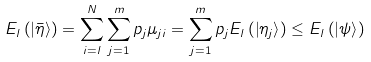Convert formula to latex. <formula><loc_0><loc_0><loc_500><loc_500>E _ { l } \left ( \left | \bar { \eta } \right \rangle \right ) = \sum _ { i = l } ^ { N } \sum _ { j = 1 } ^ { m } p _ { j } \mu _ { j i } = \sum _ { j = 1 } ^ { m } p _ { j } E _ { l } \left ( \left | \eta _ { j } \right \rangle \right ) \leq E _ { l } \left ( \left | \psi \right \rangle \right )</formula> 